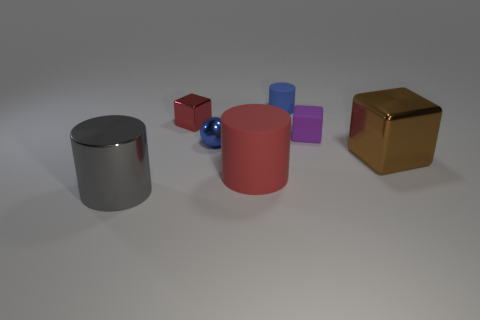Can you guess the size of the objects in relation to each other? Based on their proportions in the image, the gold cube seems to be the largest object, followed by the red and grey cylinders that are similar in height. The smaller cubes and the sphere are much smaller in comparison, suggesting a variety of scales, which adds visual interest to the scene. 